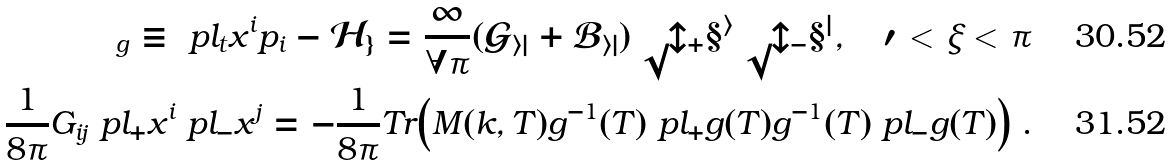<formula> <loc_0><loc_0><loc_500><loc_500>\sl _ { g } \equiv \ p l _ { t } x ^ { i } p _ { i } - \mathcal { H } _ { g } = \frac { 1 } { 8 \pi } ( G _ { i j } + B _ { i j } ) \ p l _ { + } x ^ { i } \ p l _ { - } x ^ { j } , \quad 0 < \xi < \pi \\ \frac { 1 } { 8 \pi } G _ { i j } \ p l _ { + } x ^ { i } \ p l _ { - } x ^ { j } = - \frac { 1 } { 8 \pi } T r \Big { ( } M ( k , T ) g ^ { - 1 } ( T ) \ p l _ { + } g ( T ) g ^ { - 1 } ( T ) \ p l _ { - } g ( T ) \Big { ) } \ .</formula> 